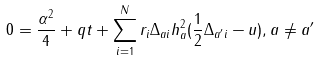Convert formula to latex. <formula><loc_0><loc_0><loc_500><loc_500>0 = \frac { \alpha ^ { 2 } } { 4 } + q t + \sum _ { i = 1 } ^ { N } r _ { i } \Delta _ { a i } h _ { a } ^ { 2 } ( \frac { 1 } { 2 } \Delta _ { a ^ { \prime } i } - u ) , a \not = a ^ { \prime }</formula> 